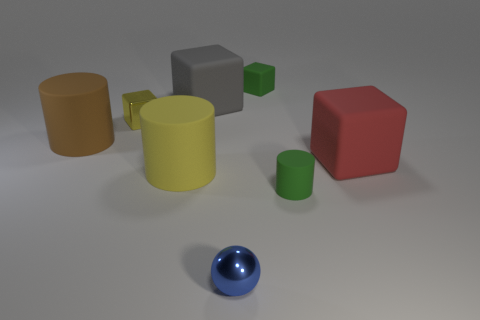What material is the small ball?
Your answer should be very brief. Metal. What number of other objects are the same material as the large brown object?
Offer a terse response. 5. There is a cylinder that is both in front of the red matte block and behind the tiny green cylinder; how big is it?
Offer a very short reply. Large. There is a small rubber object in front of the matte cube to the left of the ball; what shape is it?
Make the answer very short. Cylinder. Is there anything else that is the same shape as the blue metallic thing?
Provide a succinct answer. No. Is the number of green rubber things in front of the gray rubber cube the same as the number of yellow cylinders?
Provide a short and direct response. Yes. Does the shiny block have the same color as the big cylinder that is in front of the red matte thing?
Provide a short and direct response. Yes. What color is the tiny thing that is both left of the green cube and in front of the big yellow cylinder?
Offer a terse response. Blue. How many things are to the left of the tiny thing in front of the tiny rubber cylinder?
Ensure brevity in your answer.  4. Are there any small rubber things of the same shape as the big yellow thing?
Ensure brevity in your answer.  Yes. 